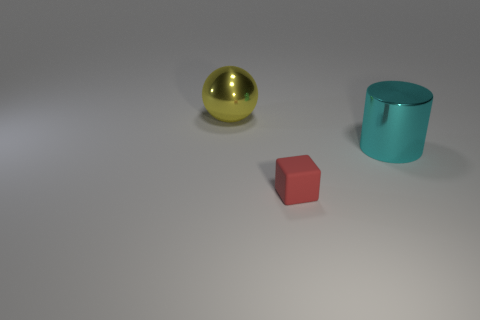There is a large metallic object that is right of the red rubber thing; what number of cyan metal cylinders are behind it?
Offer a terse response. 0. There is a metallic object that is to the right of the big metal object that is behind the shiny thing that is right of the yellow ball; what is its size?
Provide a short and direct response. Large. How many things are large things on the left side of the big cyan thing or shiny objects left of the big cyan shiny cylinder?
Your response must be concise. 1. There is a shiny thing that is right of the yellow metal ball that is behind the small thing; what shape is it?
Ensure brevity in your answer.  Cylinder. Are there any other things that are the same size as the red matte cube?
Ensure brevity in your answer.  No. How many objects are rubber things or big shiny cylinders?
Your response must be concise. 2. Is there a yellow object of the same size as the cylinder?
Your answer should be very brief. Yes. The large yellow thing is what shape?
Your answer should be compact. Sphere. Are there more things that are on the right side of the red rubber block than big spheres to the left of the big shiny ball?
Give a very brief answer. Yes. There is a yellow metal thing that is the same size as the cyan cylinder; what shape is it?
Provide a short and direct response. Sphere. 